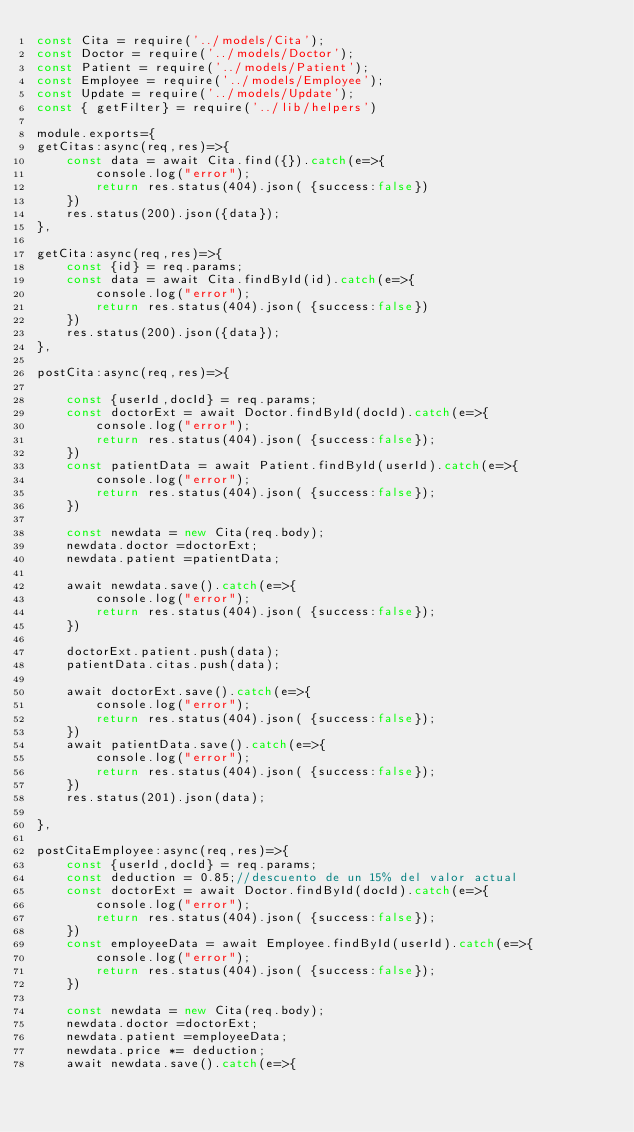Convert code to text. <code><loc_0><loc_0><loc_500><loc_500><_JavaScript_>const Cita = require('../models/Cita');
const Doctor = require('../models/Doctor');
const Patient = require('../models/Patient');
const Employee = require('../models/Employee');
const Update = require('../models/Update');
const { getFilter} = require('../lib/helpers')

module.exports={
getCitas:async(req,res)=>{    
    const data = await Cita.find({}).catch(e=>{
        console.log("error");
        return res.status(404).json( {success:false})            
    })
    res.status(200).json({data});
},

getCita:async(req,res)=>{
    const {id} = req.params;       
    const data = await Cita.findById(id).catch(e=>{
        console.log("error");
        return res.status(404).json( {success:false})            
    })
    res.status(200).json({data});
},

postCita:async(req,res)=>{
    
    const {userId,docId} = req.params;
    const doctorExt = await Doctor.findById(docId).catch(e=>{
        console.log("error");
        return res.status(404).json( {success:false});
    })
    const patientData = await Patient.findById(userId).catch(e=>{
        console.log("error");
        return res.status(404).json( {success:false});           
    })
    
    const newdata = new Cita(req.body);
    newdata.doctor =doctorExt;
    newdata.patient =patientData;

    await newdata.save().catch(e=>{
        console.log("error");
        return res.status(404).json( {success:false});
    })
    
    doctorExt.patient.push(data);
    patientData.citas.push(data);
    
    await doctorExt.save().catch(e=>{
        console.log("error");
        return res.status(404).json( {success:false});           
    })
    await patientData.save().catch(e=>{
        console.log("error");
        return res.status(404).json( {success:false});           
    })
    res.status(201).json(data);
 
},

postCitaEmployee:async(req,res)=>{    
    const {userId,docId} = req.params;
    const deduction = 0.85;//descuento de un 15% del valor actual
    const doctorExt = await Doctor.findById(docId).catch(e=>{
        console.log("error");
        return res.status(404).json( {success:false});
    })
    const employeeData = await Employee.findById(userId).catch(e=>{
        console.log("error");
        return res.status(404).json( {success:false});           
    })
    
    const newdata = new Cita(req.body);
    newdata.doctor =doctorExt;
    newdata.patient =employeeData;
    newdata.price *= deduction;
    await newdata.save().catch(e=>{</code> 